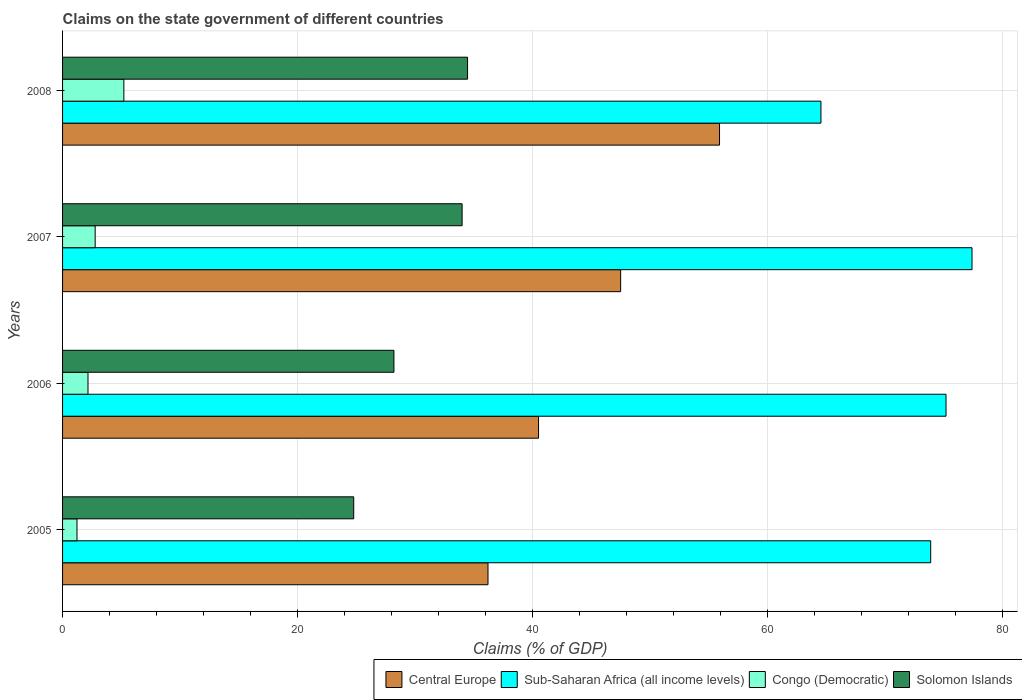How many different coloured bars are there?
Your answer should be compact. 4. How many groups of bars are there?
Ensure brevity in your answer.  4. Are the number of bars on each tick of the Y-axis equal?
Give a very brief answer. Yes. How many bars are there on the 2nd tick from the top?
Make the answer very short. 4. How many bars are there on the 4th tick from the bottom?
Ensure brevity in your answer.  4. What is the label of the 2nd group of bars from the top?
Your answer should be very brief. 2007. In how many cases, is the number of bars for a given year not equal to the number of legend labels?
Your response must be concise. 0. What is the percentage of GDP claimed on the state government in Solomon Islands in 2007?
Provide a short and direct response. 34.01. Across all years, what is the maximum percentage of GDP claimed on the state government in Sub-Saharan Africa (all income levels)?
Ensure brevity in your answer.  77.42. Across all years, what is the minimum percentage of GDP claimed on the state government in Congo (Democratic)?
Your response must be concise. 1.23. In which year was the percentage of GDP claimed on the state government in Solomon Islands minimum?
Ensure brevity in your answer.  2005. What is the total percentage of GDP claimed on the state government in Sub-Saharan Africa (all income levels) in the graph?
Ensure brevity in your answer.  291.1. What is the difference between the percentage of GDP claimed on the state government in Solomon Islands in 2007 and that in 2008?
Keep it short and to the point. -0.46. What is the difference between the percentage of GDP claimed on the state government in Central Europe in 2008 and the percentage of GDP claimed on the state government in Congo (Democratic) in 2007?
Make the answer very short. 53.15. What is the average percentage of GDP claimed on the state government in Congo (Democratic) per year?
Make the answer very short. 2.85. In the year 2008, what is the difference between the percentage of GDP claimed on the state government in Congo (Democratic) and percentage of GDP claimed on the state government in Sub-Saharan Africa (all income levels)?
Make the answer very short. -59.35. What is the ratio of the percentage of GDP claimed on the state government in Congo (Democratic) in 2006 to that in 2008?
Your answer should be very brief. 0.41. Is the difference between the percentage of GDP claimed on the state government in Congo (Democratic) in 2006 and 2007 greater than the difference between the percentage of GDP claimed on the state government in Sub-Saharan Africa (all income levels) in 2006 and 2007?
Offer a very short reply. Yes. What is the difference between the highest and the second highest percentage of GDP claimed on the state government in Central Europe?
Your answer should be compact. 8.42. What is the difference between the highest and the lowest percentage of GDP claimed on the state government in Sub-Saharan Africa (all income levels)?
Provide a succinct answer. 12.86. Is the sum of the percentage of GDP claimed on the state government in Congo (Democratic) in 2006 and 2007 greater than the maximum percentage of GDP claimed on the state government in Solomon Islands across all years?
Keep it short and to the point. No. What does the 3rd bar from the top in 2006 represents?
Offer a terse response. Sub-Saharan Africa (all income levels). What does the 4th bar from the bottom in 2007 represents?
Offer a terse response. Solomon Islands. How many bars are there?
Keep it short and to the point. 16. Are all the bars in the graph horizontal?
Offer a very short reply. Yes. How many years are there in the graph?
Keep it short and to the point. 4. What is the difference between two consecutive major ticks on the X-axis?
Provide a short and direct response. 20. Are the values on the major ticks of X-axis written in scientific E-notation?
Your response must be concise. No. Does the graph contain grids?
Your response must be concise. Yes. How many legend labels are there?
Offer a terse response. 4. How are the legend labels stacked?
Keep it short and to the point. Horizontal. What is the title of the graph?
Offer a very short reply. Claims on the state government of different countries. What is the label or title of the X-axis?
Your answer should be very brief. Claims (% of GDP). What is the label or title of the Y-axis?
Provide a short and direct response. Years. What is the Claims (% of GDP) of Central Europe in 2005?
Your answer should be compact. 36.22. What is the Claims (% of GDP) in Sub-Saharan Africa (all income levels) in 2005?
Ensure brevity in your answer.  73.91. What is the Claims (% of GDP) in Congo (Democratic) in 2005?
Give a very brief answer. 1.23. What is the Claims (% of GDP) of Solomon Islands in 2005?
Offer a terse response. 24.79. What is the Claims (% of GDP) of Central Europe in 2006?
Give a very brief answer. 40.52. What is the Claims (% of GDP) in Sub-Saharan Africa (all income levels) in 2006?
Ensure brevity in your answer.  75.21. What is the Claims (% of GDP) of Congo (Democratic) in 2006?
Your answer should be very brief. 2.16. What is the Claims (% of GDP) in Solomon Islands in 2006?
Give a very brief answer. 28.21. What is the Claims (% of GDP) of Central Europe in 2007?
Provide a succinct answer. 47.51. What is the Claims (% of GDP) in Sub-Saharan Africa (all income levels) in 2007?
Provide a short and direct response. 77.42. What is the Claims (% of GDP) in Congo (Democratic) in 2007?
Give a very brief answer. 2.78. What is the Claims (% of GDP) of Solomon Islands in 2007?
Ensure brevity in your answer.  34.01. What is the Claims (% of GDP) of Central Europe in 2008?
Provide a succinct answer. 55.93. What is the Claims (% of GDP) of Sub-Saharan Africa (all income levels) in 2008?
Provide a short and direct response. 64.56. What is the Claims (% of GDP) in Congo (Democratic) in 2008?
Ensure brevity in your answer.  5.22. What is the Claims (% of GDP) in Solomon Islands in 2008?
Ensure brevity in your answer.  34.48. Across all years, what is the maximum Claims (% of GDP) of Central Europe?
Your response must be concise. 55.93. Across all years, what is the maximum Claims (% of GDP) of Sub-Saharan Africa (all income levels)?
Provide a succinct answer. 77.42. Across all years, what is the maximum Claims (% of GDP) in Congo (Democratic)?
Your answer should be compact. 5.22. Across all years, what is the maximum Claims (% of GDP) of Solomon Islands?
Ensure brevity in your answer.  34.48. Across all years, what is the minimum Claims (% of GDP) in Central Europe?
Provide a succinct answer. 36.22. Across all years, what is the minimum Claims (% of GDP) in Sub-Saharan Africa (all income levels)?
Your answer should be very brief. 64.56. Across all years, what is the minimum Claims (% of GDP) in Congo (Democratic)?
Ensure brevity in your answer.  1.23. Across all years, what is the minimum Claims (% of GDP) of Solomon Islands?
Give a very brief answer. 24.79. What is the total Claims (% of GDP) in Central Europe in the graph?
Provide a succinct answer. 180.18. What is the total Claims (% of GDP) in Sub-Saharan Africa (all income levels) in the graph?
Make the answer very short. 291.1. What is the total Claims (% of GDP) of Congo (Democratic) in the graph?
Your answer should be very brief. 11.39. What is the total Claims (% of GDP) in Solomon Islands in the graph?
Keep it short and to the point. 121.49. What is the difference between the Claims (% of GDP) of Central Europe in 2005 and that in 2006?
Your answer should be very brief. -4.3. What is the difference between the Claims (% of GDP) in Sub-Saharan Africa (all income levels) in 2005 and that in 2006?
Make the answer very short. -1.31. What is the difference between the Claims (% of GDP) in Congo (Democratic) in 2005 and that in 2006?
Keep it short and to the point. -0.94. What is the difference between the Claims (% of GDP) in Solomon Islands in 2005 and that in 2006?
Your response must be concise. -3.42. What is the difference between the Claims (% of GDP) in Central Europe in 2005 and that in 2007?
Give a very brief answer. -11.29. What is the difference between the Claims (% of GDP) of Sub-Saharan Africa (all income levels) in 2005 and that in 2007?
Offer a terse response. -3.52. What is the difference between the Claims (% of GDP) of Congo (Democratic) in 2005 and that in 2007?
Provide a succinct answer. -1.55. What is the difference between the Claims (% of GDP) in Solomon Islands in 2005 and that in 2007?
Your response must be concise. -9.23. What is the difference between the Claims (% of GDP) of Central Europe in 2005 and that in 2008?
Offer a terse response. -19.71. What is the difference between the Claims (% of GDP) in Sub-Saharan Africa (all income levels) in 2005 and that in 2008?
Offer a very short reply. 9.34. What is the difference between the Claims (% of GDP) of Congo (Democratic) in 2005 and that in 2008?
Offer a very short reply. -3.99. What is the difference between the Claims (% of GDP) of Solomon Islands in 2005 and that in 2008?
Offer a terse response. -9.69. What is the difference between the Claims (% of GDP) of Central Europe in 2006 and that in 2007?
Give a very brief answer. -6.99. What is the difference between the Claims (% of GDP) of Sub-Saharan Africa (all income levels) in 2006 and that in 2007?
Keep it short and to the point. -2.21. What is the difference between the Claims (% of GDP) in Congo (Democratic) in 2006 and that in 2007?
Your response must be concise. -0.61. What is the difference between the Claims (% of GDP) of Solomon Islands in 2006 and that in 2007?
Make the answer very short. -5.8. What is the difference between the Claims (% of GDP) of Central Europe in 2006 and that in 2008?
Your response must be concise. -15.41. What is the difference between the Claims (% of GDP) of Sub-Saharan Africa (all income levels) in 2006 and that in 2008?
Your response must be concise. 10.65. What is the difference between the Claims (% of GDP) of Congo (Democratic) in 2006 and that in 2008?
Make the answer very short. -3.05. What is the difference between the Claims (% of GDP) in Solomon Islands in 2006 and that in 2008?
Your answer should be compact. -6.27. What is the difference between the Claims (% of GDP) in Central Europe in 2007 and that in 2008?
Make the answer very short. -8.42. What is the difference between the Claims (% of GDP) in Sub-Saharan Africa (all income levels) in 2007 and that in 2008?
Your answer should be compact. 12.86. What is the difference between the Claims (% of GDP) of Congo (Democratic) in 2007 and that in 2008?
Your answer should be very brief. -2.44. What is the difference between the Claims (% of GDP) of Solomon Islands in 2007 and that in 2008?
Your answer should be compact. -0.46. What is the difference between the Claims (% of GDP) of Central Europe in 2005 and the Claims (% of GDP) of Sub-Saharan Africa (all income levels) in 2006?
Give a very brief answer. -38.99. What is the difference between the Claims (% of GDP) in Central Europe in 2005 and the Claims (% of GDP) in Congo (Democratic) in 2006?
Offer a very short reply. 34.05. What is the difference between the Claims (% of GDP) in Central Europe in 2005 and the Claims (% of GDP) in Solomon Islands in 2006?
Your answer should be very brief. 8.01. What is the difference between the Claims (% of GDP) in Sub-Saharan Africa (all income levels) in 2005 and the Claims (% of GDP) in Congo (Democratic) in 2006?
Provide a short and direct response. 71.74. What is the difference between the Claims (% of GDP) of Sub-Saharan Africa (all income levels) in 2005 and the Claims (% of GDP) of Solomon Islands in 2006?
Provide a succinct answer. 45.69. What is the difference between the Claims (% of GDP) in Congo (Democratic) in 2005 and the Claims (% of GDP) in Solomon Islands in 2006?
Your response must be concise. -26.98. What is the difference between the Claims (% of GDP) in Central Europe in 2005 and the Claims (% of GDP) in Sub-Saharan Africa (all income levels) in 2007?
Keep it short and to the point. -41.21. What is the difference between the Claims (% of GDP) in Central Europe in 2005 and the Claims (% of GDP) in Congo (Democratic) in 2007?
Your response must be concise. 33.44. What is the difference between the Claims (% of GDP) in Central Europe in 2005 and the Claims (% of GDP) in Solomon Islands in 2007?
Provide a succinct answer. 2.2. What is the difference between the Claims (% of GDP) of Sub-Saharan Africa (all income levels) in 2005 and the Claims (% of GDP) of Congo (Democratic) in 2007?
Provide a succinct answer. 71.13. What is the difference between the Claims (% of GDP) in Sub-Saharan Africa (all income levels) in 2005 and the Claims (% of GDP) in Solomon Islands in 2007?
Provide a short and direct response. 39.89. What is the difference between the Claims (% of GDP) of Congo (Democratic) in 2005 and the Claims (% of GDP) of Solomon Islands in 2007?
Make the answer very short. -32.78. What is the difference between the Claims (% of GDP) of Central Europe in 2005 and the Claims (% of GDP) of Sub-Saharan Africa (all income levels) in 2008?
Offer a terse response. -28.35. What is the difference between the Claims (% of GDP) in Central Europe in 2005 and the Claims (% of GDP) in Congo (Democratic) in 2008?
Make the answer very short. 31. What is the difference between the Claims (% of GDP) of Central Europe in 2005 and the Claims (% of GDP) of Solomon Islands in 2008?
Your response must be concise. 1.74. What is the difference between the Claims (% of GDP) of Sub-Saharan Africa (all income levels) in 2005 and the Claims (% of GDP) of Congo (Democratic) in 2008?
Your answer should be compact. 68.69. What is the difference between the Claims (% of GDP) in Sub-Saharan Africa (all income levels) in 2005 and the Claims (% of GDP) in Solomon Islands in 2008?
Offer a terse response. 39.43. What is the difference between the Claims (% of GDP) of Congo (Democratic) in 2005 and the Claims (% of GDP) of Solomon Islands in 2008?
Your answer should be very brief. -33.25. What is the difference between the Claims (% of GDP) of Central Europe in 2006 and the Claims (% of GDP) of Sub-Saharan Africa (all income levels) in 2007?
Provide a succinct answer. -36.9. What is the difference between the Claims (% of GDP) of Central Europe in 2006 and the Claims (% of GDP) of Congo (Democratic) in 2007?
Your response must be concise. 37.74. What is the difference between the Claims (% of GDP) of Central Europe in 2006 and the Claims (% of GDP) of Solomon Islands in 2007?
Provide a succinct answer. 6.51. What is the difference between the Claims (% of GDP) of Sub-Saharan Africa (all income levels) in 2006 and the Claims (% of GDP) of Congo (Democratic) in 2007?
Provide a short and direct response. 72.43. What is the difference between the Claims (% of GDP) in Sub-Saharan Africa (all income levels) in 2006 and the Claims (% of GDP) in Solomon Islands in 2007?
Offer a very short reply. 41.2. What is the difference between the Claims (% of GDP) of Congo (Democratic) in 2006 and the Claims (% of GDP) of Solomon Islands in 2007?
Your response must be concise. -31.85. What is the difference between the Claims (% of GDP) in Central Europe in 2006 and the Claims (% of GDP) in Sub-Saharan Africa (all income levels) in 2008?
Ensure brevity in your answer.  -24.04. What is the difference between the Claims (% of GDP) of Central Europe in 2006 and the Claims (% of GDP) of Congo (Democratic) in 2008?
Your answer should be very brief. 35.3. What is the difference between the Claims (% of GDP) in Central Europe in 2006 and the Claims (% of GDP) in Solomon Islands in 2008?
Make the answer very short. 6.04. What is the difference between the Claims (% of GDP) of Sub-Saharan Africa (all income levels) in 2006 and the Claims (% of GDP) of Congo (Democratic) in 2008?
Ensure brevity in your answer.  69.99. What is the difference between the Claims (% of GDP) of Sub-Saharan Africa (all income levels) in 2006 and the Claims (% of GDP) of Solomon Islands in 2008?
Make the answer very short. 40.73. What is the difference between the Claims (% of GDP) of Congo (Democratic) in 2006 and the Claims (% of GDP) of Solomon Islands in 2008?
Ensure brevity in your answer.  -32.31. What is the difference between the Claims (% of GDP) in Central Europe in 2007 and the Claims (% of GDP) in Sub-Saharan Africa (all income levels) in 2008?
Offer a terse response. -17.05. What is the difference between the Claims (% of GDP) of Central Europe in 2007 and the Claims (% of GDP) of Congo (Democratic) in 2008?
Your answer should be very brief. 42.29. What is the difference between the Claims (% of GDP) in Central Europe in 2007 and the Claims (% of GDP) in Solomon Islands in 2008?
Keep it short and to the point. 13.03. What is the difference between the Claims (% of GDP) of Sub-Saharan Africa (all income levels) in 2007 and the Claims (% of GDP) of Congo (Democratic) in 2008?
Make the answer very short. 72.21. What is the difference between the Claims (% of GDP) in Sub-Saharan Africa (all income levels) in 2007 and the Claims (% of GDP) in Solomon Islands in 2008?
Give a very brief answer. 42.95. What is the difference between the Claims (% of GDP) of Congo (Democratic) in 2007 and the Claims (% of GDP) of Solomon Islands in 2008?
Offer a terse response. -31.7. What is the average Claims (% of GDP) of Central Europe per year?
Ensure brevity in your answer.  45.04. What is the average Claims (% of GDP) of Sub-Saharan Africa (all income levels) per year?
Ensure brevity in your answer.  72.78. What is the average Claims (% of GDP) of Congo (Democratic) per year?
Keep it short and to the point. 2.85. What is the average Claims (% of GDP) of Solomon Islands per year?
Offer a very short reply. 30.37. In the year 2005, what is the difference between the Claims (% of GDP) of Central Europe and Claims (% of GDP) of Sub-Saharan Africa (all income levels)?
Your answer should be very brief. -37.69. In the year 2005, what is the difference between the Claims (% of GDP) in Central Europe and Claims (% of GDP) in Congo (Democratic)?
Keep it short and to the point. 34.99. In the year 2005, what is the difference between the Claims (% of GDP) in Central Europe and Claims (% of GDP) in Solomon Islands?
Offer a terse response. 11.43. In the year 2005, what is the difference between the Claims (% of GDP) in Sub-Saharan Africa (all income levels) and Claims (% of GDP) in Congo (Democratic)?
Your response must be concise. 72.68. In the year 2005, what is the difference between the Claims (% of GDP) in Sub-Saharan Africa (all income levels) and Claims (% of GDP) in Solomon Islands?
Offer a terse response. 49.12. In the year 2005, what is the difference between the Claims (% of GDP) of Congo (Democratic) and Claims (% of GDP) of Solomon Islands?
Give a very brief answer. -23.56. In the year 2006, what is the difference between the Claims (% of GDP) of Central Europe and Claims (% of GDP) of Sub-Saharan Africa (all income levels)?
Your answer should be very brief. -34.69. In the year 2006, what is the difference between the Claims (% of GDP) in Central Europe and Claims (% of GDP) in Congo (Democratic)?
Offer a terse response. 38.36. In the year 2006, what is the difference between the Claims (% of GDP) in Central Europe and Claims (% of GDP) in Solomon Islands?
Provide a succinct answer. 12.31. In the year 2006, what is the difference between the Claims (% of GDP) of Sub-Saharan Africa (all income levels) and Claims (% of GDP) of Congo (Democratic)?
Keep it short and to the point. 73.05. In the year 2006, what is the difference between the Claims (% of GDP) of Sub-Saharan Africa (all income levels) and Claims (% of GDP) of Solomon Islands?
Ensure brevity in your answer.  47. In the year 2006, what is the difference between the Claims (% of GDP) of Congo (Democratic) and Claims (% of GDP) of Solomon Islands?
Make the answer very short. -26.05. In the year 2007, what is the difference between the Claims (% of GDP) of Central Europe and Claims (% of GDP) of Sub-Saharan Africa (all income levels)?
Keep it short and to the point. -29.91. In the year 2007, what is the difference between the Claims (% of GDP) in Central Europe and Claims (% of GDP) in Congo (Democratic)?
Provide a short and direct response. 44.73. In the year 2007, what is the difference between the Claims (% of GDP) of Central Europe and Claims (% of GDP) of Solomon Islands?
Your response must be concise. 13.5. In the year 2007, what is the difference between the Claims (% of GDP) of Sub-Saharan Africa (all income levels) and Claims (% of GDP) of Congo (Democratic)?
Your answer should be very brief. 74.65. In the year 2007, what is the difference between the Claims (% of GDP) of Sub-Saharan Africa (all income levels) and Claims (% of GDP) of Solomon Islands?
Your response must be concise. 43.41. In the year 2007, what is the difference between the Claims (% of GDP) of Congo (Democratic) and Claims (% of GDP) of Solomon Islands?
Offer a terse response. -31.24. In the year 2008, what is the difference between the Claims (% of GDP) in Central Europe and Claims (% of GDP) in Sub-Saharan Africa (all income levels)?
Keep it short and to the point. -8.63. In the year 2008, what is the difference between the Claims (% of GDP) of Central Europe and Claims (% of GDP) of Congo (Democratic)?
Provide a succinct answer. 50.71. In the year 2008, what is the difference between the Claims (% of GDP) of Central Europe and Claims (% of GDP) of Solomon Islands?
Provide a succinct answer. 21.45. In the year 2008, what is the difference between the Claims (% of GDP) in Sub-Saharan Africa (all income levels) and Claims (% of GDP) in Congo (Democratic)?
Offer a very short reply. 59.35. In the year 2008, what is the difference between the Claims (% of GDP) of Sub-Saharan Africa (all income levels) and Claims (% of GDP) of Solomon Islands?
Your response must be concise. 30.09. In the year 2008, what is the difference between the Claims (% of GDP) in Congo (Democratic) and Claims (% of GDP) in Solomon Islands?
Make the answer very short. -29.26. What is the ratio of the Claims (% of GDP) of Central Europe in 2005 to that in 2006?
Give a very brief answer. 0.89. What is the ratio of the Claims (% of GDP) of Sub-Saharan Africa (all income levels) in 2005 to that in 2006?
Ensure brevity in your answer.  0.98. What is the ratio of the Claims (% of GDP) in Congo (Democratic) in 2005 to that in 2006?
Offer a terse response. 0.57. What is the ratio of the Claims (% of GDP) in Solomon Islands in 2005 to that in 2006?
Keep it short and to the point. 0.88. What is the ratio of the Claims (% of GDP) in Central Europe in 2005 to that in 2007?
Your answer should be compact. 0.76. What is the ratio of the Claims (% of GDP) in Sub-Saharan Africa (all income levels) in 2005 to that in 2007?
Make the answer very short. 0.95. What is the ratio of the Claims (% of GDP) in Congo (Democratic) in 2005 to that in 2007?
Your answer should be compact. 0.44. What is the ratio of the Claims (% of GDP) of Solomon Islands in 2005 to that in 2007?
Provide a succinct answer. 0.73. What is the ratio of the Claims (% of GDP) of Central Europe in 2005 to that in 2008?
Your answer should be very brief. 0.65. What is the ratio of the Claims (% of GDP) of Sub-Saharan Africa (all income levels) in 2005 to that in 2008?
Your answer should be compact. 1.14. What is the ratio of the Claims (% of GDP) of Congo (Democratic) in 2005 to that in 2008?
Offer a very short reply. 0.24. What is the ratio of the Claims (% of GDP) of Solomon Islands in 2005 to that in 2008?
Your answer should be very brief. 0.72. What is the ratio of the Claims (% of GDP) in Central Europe in 2006 to that in 2007?
Give a very brief answer. 0.85. What is the ratio of the Claims (% of GDP) in Sub-Saharan Africa (all income levels) in 2006 to that in 2007?
Ensure brevity in your answer.  0.97. What is the ratio of the Claims (% of GDP) of Congo (Democratic) in 2006 to that in 2007?
Your answer should be compact. 0.78. What is the ratio of the Claims (% of GDP) of Solomon Islands in 2006 to that in 2007?
Give a very brief answer. 0.83. What is the ratio of the Claims (% of GDP) in Central Europe in 2006 to that in 2008?
Your answer should be very brief. 0.72. What is the ratio of the Claims (% of GDP) of Sub-Saharan Africa (all income levels) in 2006 to that in 2008?
Keep it short and to the point. 1.16. What is the ratio of the Claims (% of GDP) in Congo (Democratic) in 2006 to that in 2008?
Keep it short and to the point. 0.41. What is the ratio of the Claims (% of GDP) of Solomon Islands in 2006 to that in 2008?
Provide a short and direct response. 0.82. What is the ratio of the Claims (% of GDP) of Central Europe in 2007 to that in 2008?
Your response must be concise. 0.85. What is the ratio of the Claims (% of GDP) of Sub-Saharan Africa (all income levels) in 2007 to that in 2008?
Your response must be concise. 1.2. What is the ratio of the Claims (% of GDP) in Congo (Democratic) in 2007 to that in 2008?
Your answer should be very brief. 0.53. What is the ratio of the Claims (% of GDP) in Solomon Islands in 2007 to that in 2008?
Offer a very short reply. 0.99. What is the difference between the highest and the second highest Claims (% of GDP) of Central Europe?
Give a very brief answer. 8.42. What is the difference between the highest and the second highest Claims (% of GDP) in Sub-Saharan Africa (all income levels)?
Give a very brief answer. 2.21. What is the difference between the highest and the second highest Claims (% of GDP) of Congo (Democratic)?
Give a very brief answer. 2.44. What is the difference between the highest and the second highest Claims (% of GDP) in Solomon Islands?
Your response must be concise. 0.46. What is the difference between the highest and the lowest Claims (% of GDP) in Central Europe?
Give a very brief answer. 19.71. What is the difference between the highest and the lowest Claims (% of GDP) of Sub-Saharan Africa (all income levels)?
Make the answer very short. 12.86. What is the difference between the highest and the lowest Claims (% of GDP) in Congo (Democratic)?
Your answer should be compact. 3.99. What is the difference between the highest and the lowest Claims (% of GDP) of Solomon Islands?
Offer a terse response. 9.69. 